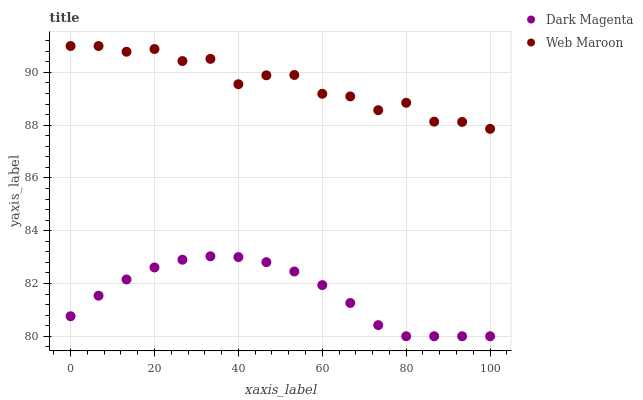Does Dark Magenta have the minimum area under the curve?
Answer yes or no. Yes. Does Web Maroon have the maximum area under the curve?
Answer yes or no. Yes. Does Dark Magenta have the maximum area under the curve?
Answer yes or no. No. Is Dark Magenta the smoothest?
Answer yes or no. Yes. Is Web Maroon the roughest?
Answer yes or no. Yes. Is Dark Magenta the roughest?
Answer yes or no. No. Does Dark Magenta have the lowest value?
Answer yes or no. Yes. Does Web Maroon have the highest value?
Answer yes or no. Yes. Does Dark Magenta have the highest value?
Answer yes or no. No. Is Dark Magenta less than Web Maroon?
Answer yes or no. Yes. Is Web Maroon greater than Dark Magenta?
Answer yes or no. Yes. Does Dark Magenta intersect Web Maroon?
Answer yes or no. No. 